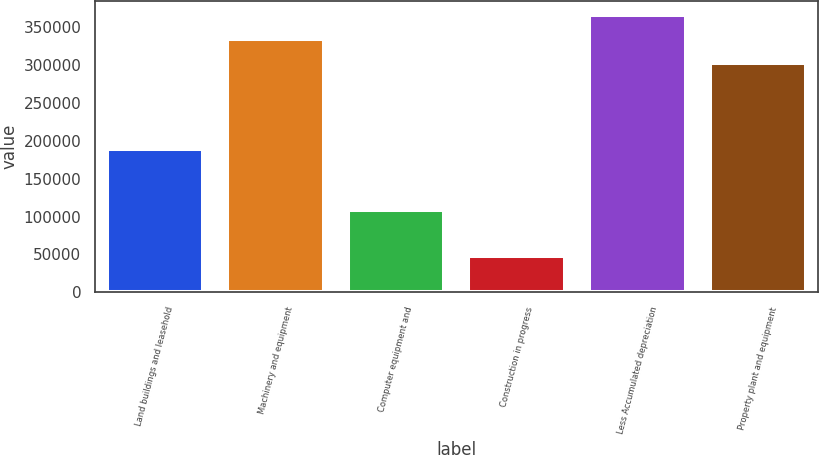Convert chart to OTSL. <chart><loc_0><loc_0><loc_500><loc_500><bar_chart><fcel>Land buildings and leasehold<fcel>Machinery and equipment<fcel>Computer equipment and<fcel>Construction in progress<fcel>Less Accumulated depreciation<fcel>Property plant and equipment<nl><fcel>188679<fcel>334279<fcel>108547<fcel>47428<fcel>365659<fcel>302899<nl></chart> 